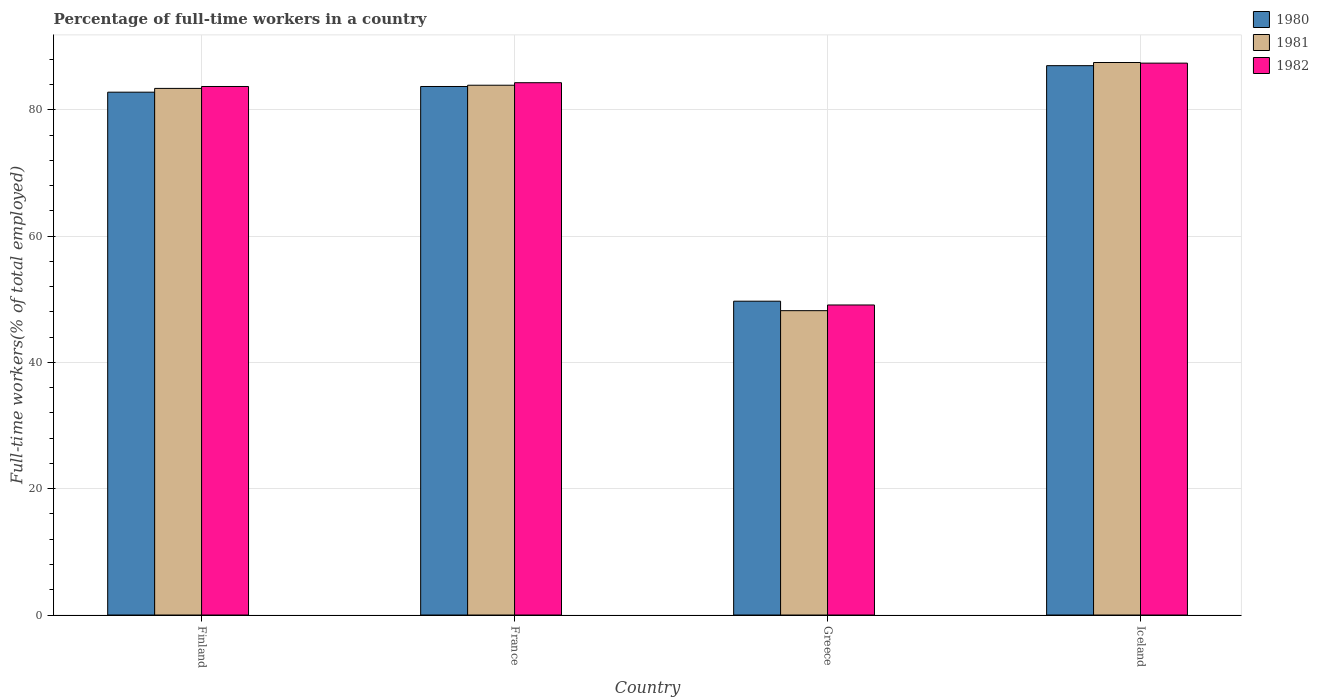How many different coloured bars are there?
Make the answer very short. 3. How many groups of bars are there?
Offer a very short reply. 4. Are the number of bars on each tick of the X-axis equal?
Offer a very short reply. Yes. How many bars are there on the 2nd tick from the right?
Your response must be concise. 3. What is the label of the 1st group of bars from the left?
Your answer should be very brief. Finland. In how many cases, is the number of bars for a given country not equal to the number of legend labels?
Ensure brevity in your answer.  0. What is the percentage of full-time workers in 1982 in Greece?
Provide a succinct answer. 49.1. Across all countries, what is the minimum percentage of full-time workers in 1981?
Provide a succinct answer. 48.2. What is the total percentage of full-time workers in 1980 in the graph?
Make the answer very short. 303.2. What is the difference between the percentage of full-time workers in 1982 in France and that in Greece?
Your response must be concise. 35.2. What is the difference between the percentage of full-time workers in 1982 in France and the percentage of full-time workers in 1981 in Finland?
Provide a short and direct response. 0.9. What is the average percentage of full-time workers in 1982 per country?
Provide a succinct answer. 76.12. What is the difference between the percentage of full-time workers of/in 1982 and percentage of full-time workers of/in 1981 in Iceland?
Ensure brevity in your answer.  -0.1. In how many countries, is the percentage of full-time workers in 1981 greater than 84 %?
Provide a short and direct response. 1. What is the ratio of the percentage of full-time workers in 1980 in Finland to that in Greece?
Your answer should be very brief. 1.67. Is the percentage of full-time workers in 1982 in Finland less than that in Iceland?
Your response must be concise. Yes. Is the difference between the percentage of full-time workers in 1982 in Greece and Iceland greater than the difference between the percentage of full-time workers in 1981 in Greece and Iceland?
Ensure brevity in your answer.  Yes. What is the difference between the highest and the second highest percentage of full-time workers in 1981?
Your response must be concise. -0.5. What is the difference between the highest and the lowest percentage of full-time workers in 1982?
Offer a terse response. 38.3. Is the sum of the percentage of full-time workers in 1981 in Finland and Iceland greater than the maximum percentage of full-time workers in 1980 across all countries?
Ensure brevity in your answer.  Yes. Is it the case that in every country, the sum of the percentage of full-time workers in 1980 and percentage of full-time workers in 1982 is greater than the percentage of full-time workers in 1981?
Provide a succinct answer. Yes. How many bars are there?
Give a very brief answer. 12. Are all the bars in the graph horizontal?
Offer a terse response. No. Are the values on the major ticks of Y-axis written in scientific E-notation?
Your answer should be compact. No. Does the graph contain grids?
Ensure brevity in your answer.  Yes. How many legend labels are there?
Your response must be concise. 3. What is the title of the graph?
Your response must be concise. Percentage of full-time workers in a country. What is the label or title of the X-axis?
Ensure brevity in your answer.  Country. What is the label or title of the Y-axis?
Provide a short and direct response. Full-time workers(% of total employed). What is the Full-time workers(% of total employed) of 1980 in Finland?
Your response must be concise. 82.8. What is the Full-time workers(% of total employed) of 1981 in Finland?
Your response must be concise. 83.4. What is the Full-time workers(% of total employed) in 1982 in Finland?
Make the answer very short. 83.7. What is the Full-time workers(% of total employed) of 1980 in France?
Your answer should be compact. 83.7. What is the Full-time workers(% of total employed) of 1981 in France?
Ensure brevity in your answer.  83.9. What is the Full-time workers(% of total employed) of 1982 in France?
Offer a terse response. 84.3. What is the Full-time workers(% of total employed) of 1980 in Greece?
Give a very brief answer. 49.7. What is the Full-time workers(% of total employed) in 1981 in Greece?
Offer a terse response. 48.2. What is the Full-time workers(% of total employed) in 1982 in Greece?
Ensure brevity in your answer.  49.1. What is the Full-time workers(% of total employed) of 1980 in Iceland?
Provide a succinct answer. 87. What is the Full-time workers(% of total employed) in 1981 in Iceland?
Provide a succinct answer. 87.5. What is the Full-time workers(% of total employed) in 1982 in Iceland?
Your response must be concise. 87.4. Across all countries, what is the maximum Full-time workers(% of total employed) in 1981?
Offer a terse response. 87.5. Across all countries, what is the maximum Full-time workers(% of total employed) in 1982?
Your answer should be very brief. 87.4. Across all countries, what is the minimum Full-time workers(% of total employed) in 1980?
Provide a short and direct response. 49.7. Across all countries, what is the minimum Full-time workers(% of total employed) in 1981?
Provide a short and direct response. 48.2. Across all countries, what is the minimum Full-time workers(% of total employed) in 1982?
Provide a short and direct response. 49.1. What is the total Full-time workers(% of total employed) in 1980 in the graph?
Offer a terse response. 303.2. What is the total Full-time workers(% of total employed) in 1981 in the graph?
Your answer should be compact. 303. What is the total Full-time workers(% of total employed) of 1982 in the graph?
Ensure brevity in your answer.  304.5. What is the difference between the Full-time workers(% of total employed) of 1981 in Finland and that in France?
Give a very brief answer. -0.5. What is the difference between the Full-time workers(% of total employed) of 1982 in Finland and that in France?
Your answer should be very brief. -0.6. What is the difference between the Full-time workers(% of total employed) in 1980 in Finland and that in Greece?
Provide a short and direct response. 33.1. What is the difference between the Full-time workers(% of total employed) of 1981 in Finland and that in Greece?
Your answer should be very brief. 35.2. What is the difference between the Full-time workers(% of total employed) of 1982 in Finland and that in Greece?
Keep it short and to the point. 34.6. What is the difference between the Full-time workers(% of total employed) in 1982 in Finland and that in Iceland?
Provide a short and direct response. -3.7. What is the difference between the Full-time workers(% of total employed) in 1981 in France and that in Greece?
Your answer should be very brief. 35.7. What is the difference between the Full-time workers(% of total employed) in 1982 in France and that in Greece?
Offer a terse response. 35.2. What is the difference between the Full-time workers(% of total employed) of 1980 in Greece and that in Iceland?
Provide a short and direct response. -37.3. What is the difference between the Full-time workers(% of total employed) in 1981 in Greece and that in Iceland?
Ensure brevity in your answer.  -39.3. What is the difference between the Full-time workers(% of total employed) in 1982 in Greece and that in Iceland?
Your response must be concise. -38.3. What is the difference between the Full-time workers(% of total employed) of 1981 in Finland and the Full-time workers(% of total employed) of 1982 in France?
Your answer should be very brief. -0.9. What is the difference between the Full-time workers(% of total employed) of 1980 in Finland and the Full-time workers(% of total employed) of 1981 in Greece?
Make the answer very short. 34.6. What is the difference between the Full-time workers(% of total employed) in 1980 in Finland and the Full-time workers(% of total employed) in 1982 in Greece?
Provide a succinct answer. 33.7. What is the difference between the Full-time workers(% of total employed) in 1981 in Finland and the Full-time workers(% of total employed) in 1982 in Greece?
Ensure brevity in your answer.  34.3. What is the difference between the Full-time workers(% of total employed) in 1980 in Finland and the Full-time workers(% of total employed) in 1981 in Iceland?
Offer a terse response. -4.7. What is the difference between the Full-time workers(% of total employed) of 1980 in Finland and the Full-time workers(% of total employed) of 1982 in Iceland?
Keep it short and to the point. -4.6. What is the difference between the Full-time workers(% of total employed) in 1980 in France and the Full-time workers(% of total employed) in 1981 in Greece?
Keep it short and to the point. 35.5. What is the difference between the Full-time workers(% of total employed) in 1980 in France and the Full-time workers(% of total employed) in 1982 in Greece?
Your answer should be very brief. 34.6. What is the difference between the Full-time workers(% of total employed) in 1981 in France and the Full-time workers(% of total employed) in 1982 in Greece?
Your answer should be very brief. 34.8. What is the difference between the Full-time workers(% of total employed) in 1980 in France and the Full-time workers(% of total employed) in 1981 in Iceland?
Provide a short and direct response. -3.8. What is the difference between the Full-time workers(% of total employed) in 1980 in France and the Full-time workers(% of total employed) in 1982 in Iceland?
Your answer should be compact. -3.7. What is the difference between the Full-time workers(% of total employed) in 1981 in France and the Full-time workers(% of total employed) in 1982 in Iceland?
Ensure brevity in your answer.  -3.5. What is the difference between the Full-time workers(% of total employed) in 1980 in Greece and the Full-time workers(% of total employed) in 1981 in Iceland?
Offer a terse response. -37.8. What is the difference between the Full-time workers(% of total employed) in 1980 in Greece and the Full-time workers(% of total employed) in 1982 in Iceland?
Your answer should be very brief. -37.7. What is the difference between the Full-time workers(% of total employed) of 1981 in Greece and the Full-time workers(% of total employed) of 1982 in Iceland?
Make the answer very short. -39.2. What is the average Full-time workers(% of total employed) in 1980 per country?
Ensure brevity in your answer.  75.8. What is the average Full-time workers(% of total employed) in 1981 per country?
Provide a succinct answer. 75.75. What is the average Full-time workers(% of total employed) of 1982 per country?
Your response must be concise. 76.12. What is the difference between the Full-time workers(% of total employed) of 1981 and Full-time workers(% of total employed) of 1982 in France?
Your response must be concise. -0.4. What is the difference between the Full-time workers(% of total employed) of 1980 and Full-time workers(% of total employed) of 1982 in Greece?
Offer a very short reply. 0.6. What is the difference between the Full-time workers(% of total employed) of 1980 and Full-time workers(% of total employed) of 1981 in Iceland?
Provide a short and direct response. -0.5. What is the difference between the Full-time workers(% of total employed) in 1981 and Full-time workers(% of total employed) in 1982 in Iceland?
Ensure brevity in your answer.  0.1. What is the ratio of the Full-time workers(% of total employed) of 1981 in Finland to that in France?
Give a very brief answer. 0.99. What is the ratio of the Full-time workers(% of total employed) of 1982 in Finland to that in France?
Offer a very short reply. 0.99. What is the ratio of the Full-time workers(% of total employed) in 1980 in Finland to that in Greece?
Give a very brief answer. 1.67. What is the ratio of the Full-time workers(% of total employed) in 1981 in Finland to that in Greece?
Your answer should be very brief. 1.73. What is the ratio of the Full-time workers(% of total employed) in 1982 in Finland to that in Greece?
Ensure brevity in your answer.  1.7. What is the ratio of the Full-time workers(% of total employed) of 1980 in Finland to that in Iceland?
Keep it short and to the point. 0.95. What is the ratio of the Full-time workers(% of total employed) in 1981 in Finland to that in Iceland?
Your response must be concise. 0.95. What is the ratio of the Full-time workers(% of total employed) in 1982 in Finland to that in Iceland?
Make the answer very short. 0.96. What is the ratio of the Full-time workers(% of total employed) in 1980 in France to that in Greece?
Your answer should be compact. 1.68. What is the ratio of the Full-time workers(% of total employed) of 1981 in France to that in Greece?
Your answer should be very brief. 1.74. What is the ratio of the Full-time workers(% of total employed) of 1982 in France to that in Greece?
Your response must be concise. 1.72. What is the ratio of the Full-time workers(% of total employed) in 1980 in France to that in Iceland?
Your answer should be very brief. 0.96. What is the ratio of the Full-time workers(% of total employed) in 1981 in France to that in Iceland?
Provide a short and direct response. 0.96. What is the ratio of the Full-time workers(% of total employed) of 1982 in France to that in Iceland?
Your answer should be very brief. 0.96. What is the ratio of the Full-time workers(% of total employed) of 1980 in Greece to that in Iceland?
Your response must be concise. 0.57. What is the ratio of the Full-time workers(% of total employed) of 1981 in Greece to that in Iceland?
Your response must be concise. 0.55. What is the ratio of the Full-time workers(% of total employed) in 1982 in Greece to that in Iceland?
Offer a terse response. 0.56. What is the difference between the highest and the second highest Full-time workers(% of total employed) of 1982?
Ensure brevity in your answer.  3.1. What is the difference between the highest and the lowest Full-time workers(% of total employed) of 1980?
Your answer should be compact. 37.3. What is the difference between the highest and the lowest Full-time workers(% of total employed) of 1981?
Make the answer very short. 39.3. What is the difference between the highest and the lowest Full-time workers(% of total employed) in 1982?
Provide a succinct answer. 38.3. 